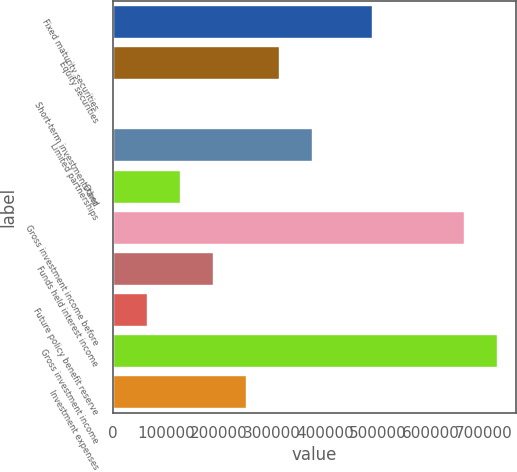Convert chart to OTSL. <chart><loc_0><loc_0><loc_500><loc_500><bar_chart><fcel>Fixed maturity securities<fcel>Equity securities<fcel>Short-term investments and<fcel>Limited partnerships<fcel>Other<fcel>Gross investment income before<fcel>Funds held interest income<fcel>Future policy benefit reserve<fcel>Gross investment income<fcel>Investment expenses<nl><fcel>489801<fcel>313943<fcel>1252<fcel>376481<fcel>126328<fcel>662740<fcel>188867<fcel>63790.2<fcel>725278<fcel>251405<nl></chart> 